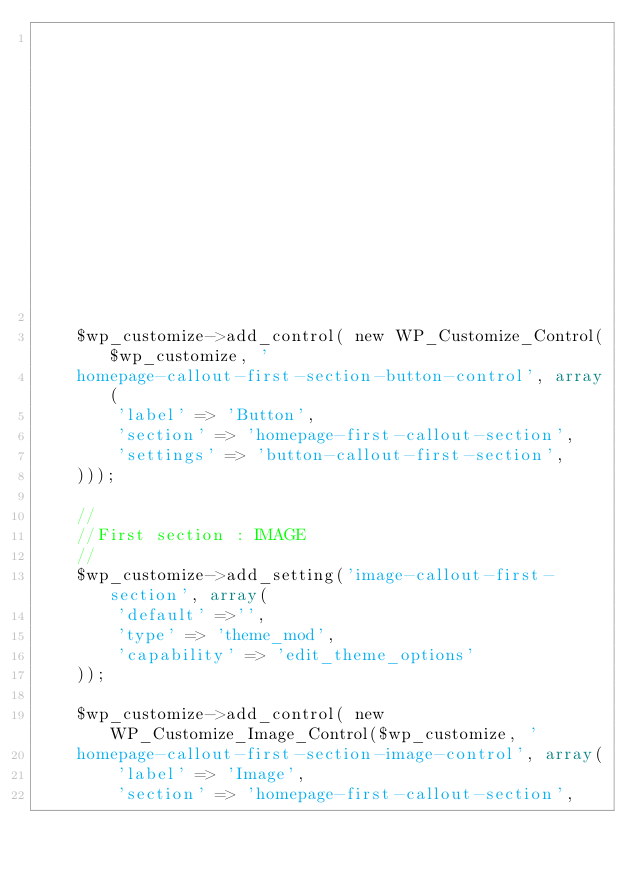<code> <loc_0><loc_0><loc_500><loc_500><_PHP_>                                                                'sanitize_callback' => 'sanitize_text_field' ));

    $wp_customize->add_control( new WP_Customize_Control($wp_customize, '
    homepage-callout-first-section-button-control', array(
        'label' => 'Button',
        'section' => 'homepage-first-callout-section',
        'settings' => 'button-callout-first-section',
    )));

    //
    //First section : IMAGE
    //
    $wp_customize->add_setting('image-callout-first-section', array(
        'default' =>'',
        'type' => 'theme_mod',
        'capability' => 'edit_theme_options'
    ));

    $wp_customize->add_control( new WP_Customize_Image_Control($wp_customize, '
    homepage-callout-first-section-image-control', array(
        'label' => 'Image',
        'section' => 'homepage-first-callout-section',</code> 